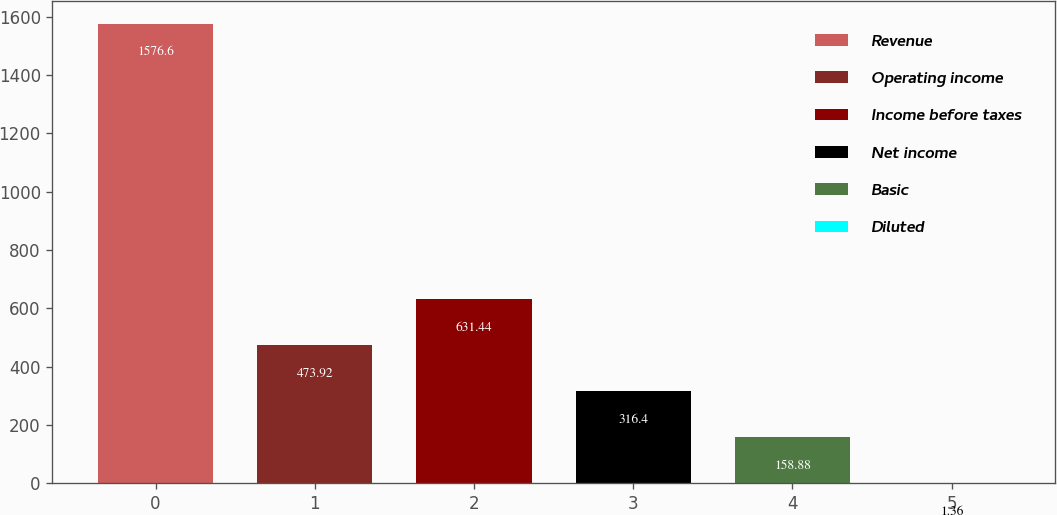Convert chart to OTSL. <chart><loc_0><loc_0><loc_500><loc_500><bar_chart><fcel>Revenue<fcel>Operating income<fcel>Income before taxes<fcel>Net income<fcel>Basic<fcel>Diluted<nl><fcel>1576.6<fcel>473.92<fcel>631.44<fcel>316.4<fcel>158.88<fcel>1.36<nl></chart> 